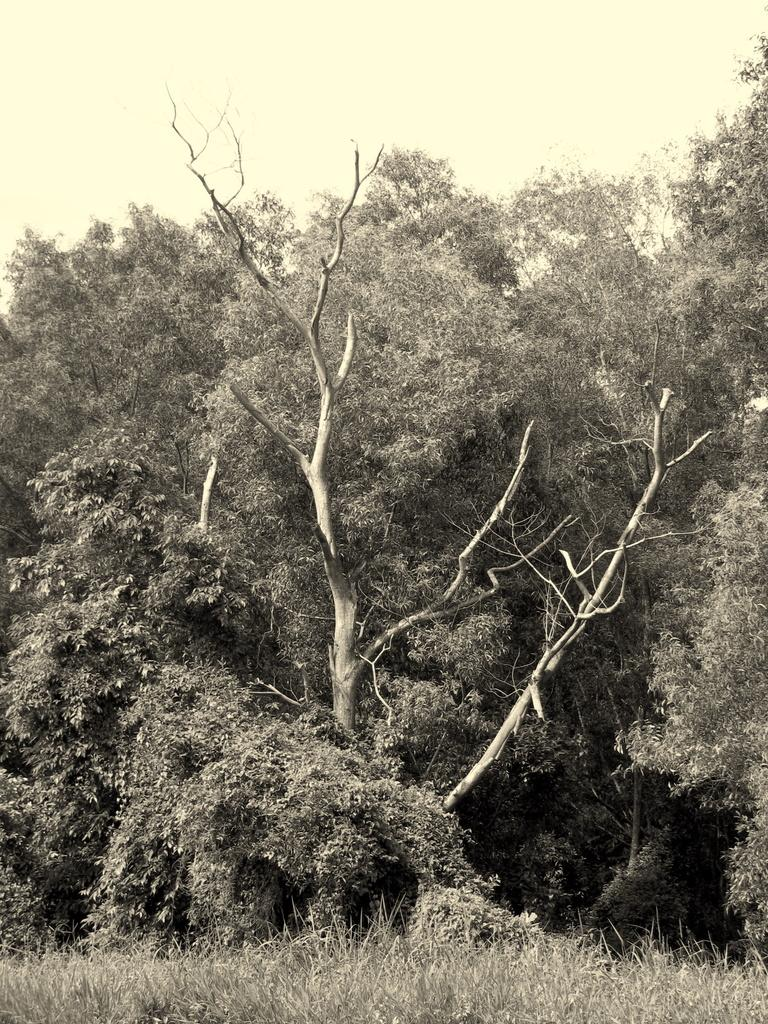What type of vegetation is in the middle of the image? There are trees in the middle of the image. What type of ground cover is visible at the bottom of the image? There is grass visible at the bottom of the image. What part of the natural environment is visible in the background of the image? The sky is visible in the background of the image. What is the cause of the cough in the image? There is no cough present in the image. What is the best way to reach the top of the trees in the image? The image does not show any means of reaching the top of the trees, and it is not possible to determine the best way from the information provided. 